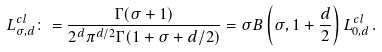Convert formula to latex. <formula><loc_0><loc_0><loc_500><loc_500>L _ { \sigma , d } ^ { c l } \colon = \frac { \Gamma ( \sigma + 1 ) } { 2 ^ { d } \pi ^ { d / 2 } \Gamma ( 1 + \sigma + d / 2 ) } = \sigma B \left ( \sigma , 1 + \frac { d } { 2 } \right ) L _ { 0 , d } ^ { c l } \, .</formula> 